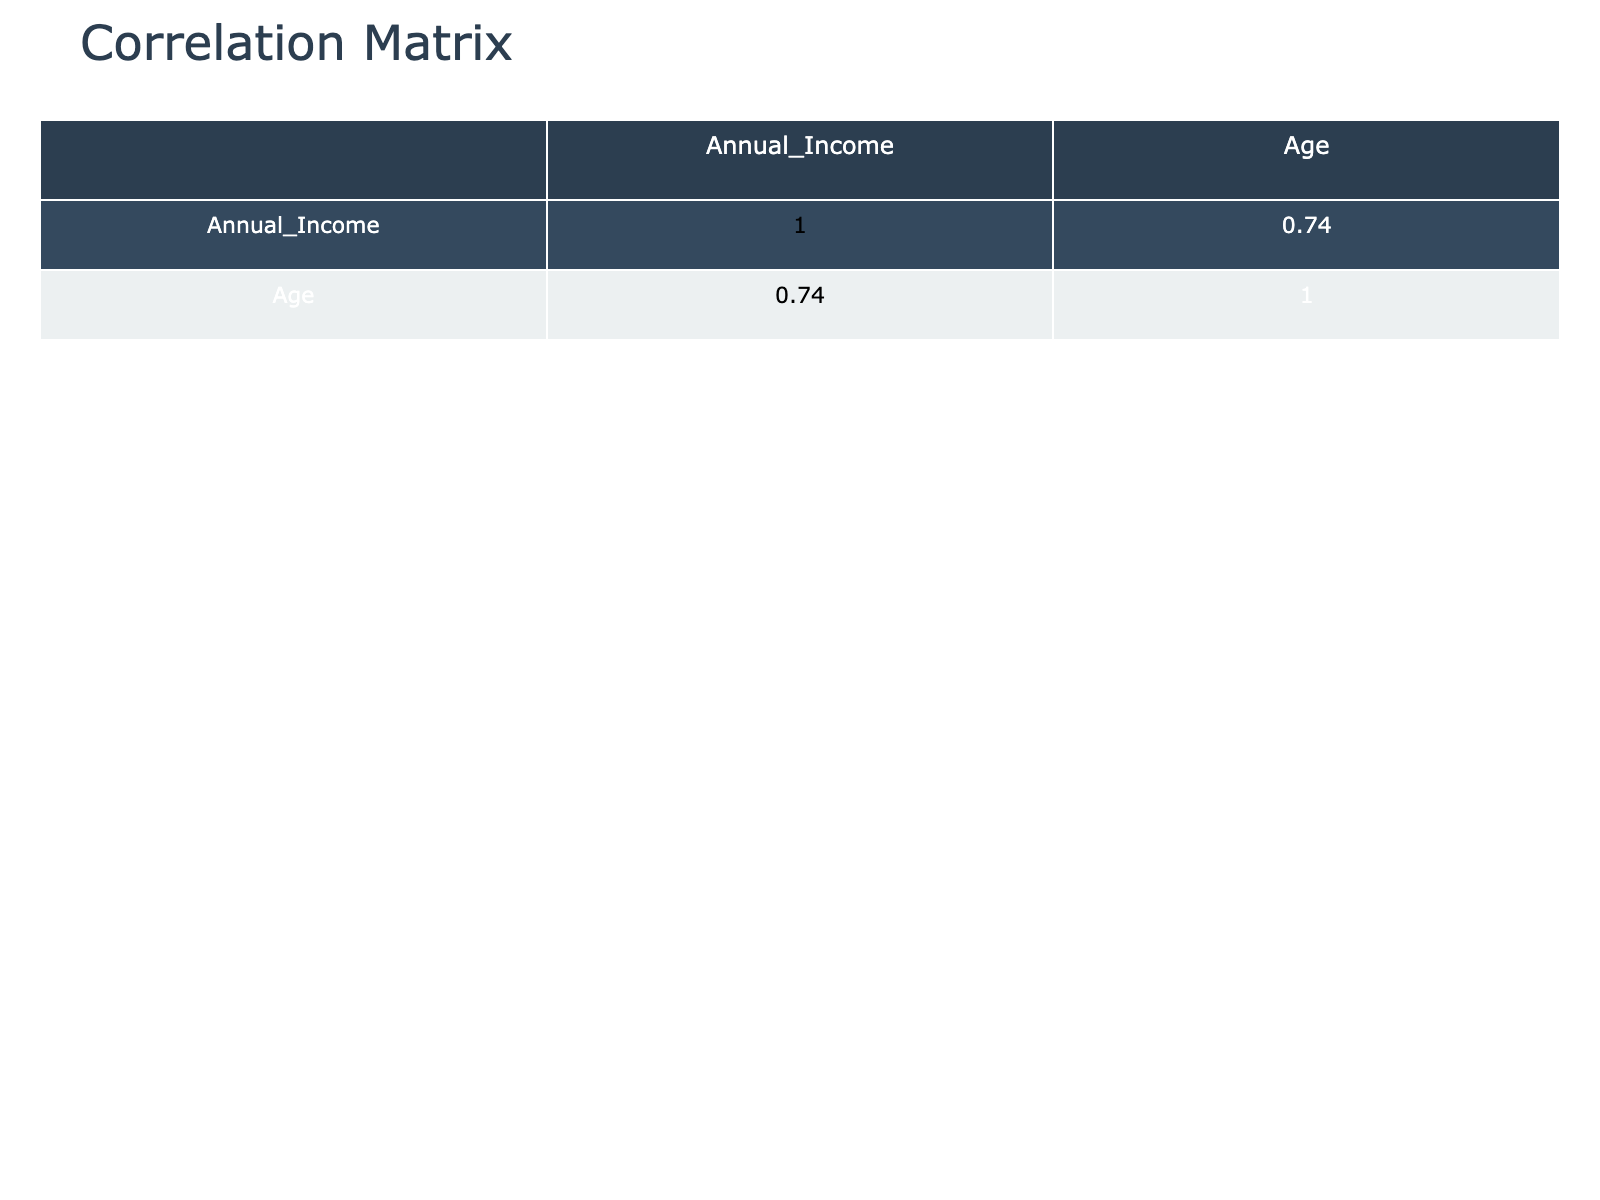What is the annual income of the Firefighter in New York? The table lists the career paths along with their respective annual incomes. To find the annual income of the Firefighter in New York, we locate the row where the Career Path is listed as Firefighter and the City as New York, which shows an annual income of 65,000.
Answer: 65000 What is the highest annual income among the listed careers? To find the highest annual income, we review the Annual Income column and identify the maximum value. The values we see are 55,000, 40,000, 60,000, 70,000, 90,000, 65,000, 45,000, 80,000, 75,000, and 50,000. The highest of these is 90,000, which corresponds to the University Professor in San Francisco.
Answer: 90000 What percentage of the careers listed require a Bachelor's degree or higher? In the table, we count the total number of career paths listed, which is 10. The following careers require a Bachelor's degree or higher: Teacher, Social Worker, University Professor, and Public Administrator, which totals 4. To find the percentage, we calculate (4/10) * 100 = 40%.
Answer: 40 Is there an Administrative Assistant listed in the table? We can check the Career Path column for the title Administrative Assistant. At a glance, there is one entry for this career in the table, confirming that it does appear.
Answer: Yes What is the average annual income for individuals with a Master's degree? We need to identify the rows with a Master's degree and then average their incomes. The careers with a Master's degree listed are: Social Worker (70,000), Public Administrator (75,000). The sum of their incomes is (70,000 + 75,000) = 145,000, and there are 2 entries, so the average is 145,000 / 2 = 72,500.
Answer: 72500 In which city does the highest-paid individual work, and what is their annual income? We check the annual incomes and find that the highest value is 90,000, corresponding to the University Professor who works in San Francisco. Thus, the highest-paid individual works in San Francisco earning 90,000.
Answer: San Francisco, 90000 How many individuals are involved in Community Involvement at a high level? Reviewing the Community Involvement column, we count the entries marked as High. They are Teacher, Social Worker, and Public Administrator for a total of 3 individuals who have high community involvement.
Answer: 3 Is there a construction worker listed with a Bachelor's degree? To answer this, we can filter through the Career Path and Educational Attainment columns. The only construction worker listed has a High School degree, indicating that there is no construction worker with a Bachelor's degree present in the table.
Answer: No 